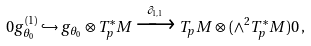Convert formula to latex. <formula><loc_0><loc_0><loc_500><loc_500>0 g _ { \theta _ { 0 } } ^ { ( 1 ) } \hookrightarrow g _ { \theta _ { 0 } } \otimes T _ { p } ^ { * } M \xrightarrow { \partial _ { 1 , 1 } } T _ { p } M \otimes ( \wedge ^ { 2 } T _ { p } ^ { * } M ) 0 \, ,</formula> 